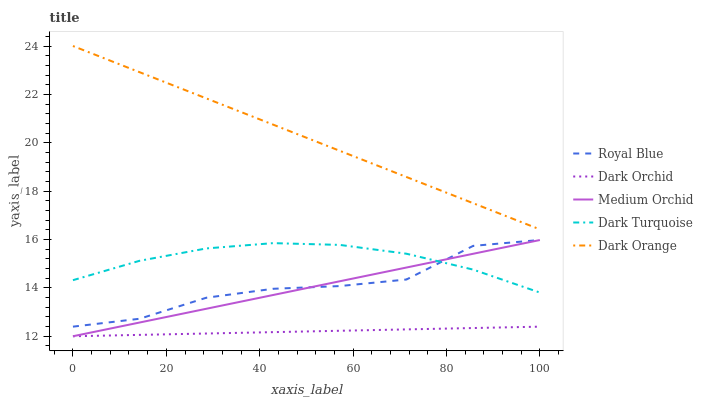Does Dark Orchid have the minimum area under the curve?
Answer yes or no. Yes. Does Dark Orange have the maximum area under the curve?
Answer yes or no. Yes. Does Royal Blue have the minimum area under the curve?
Answer yes or no. No. Does Royal Blue have the maximum area under the curve?
Answer yes or no. No. Is Dark Orchid the smoothest?
Answer yes or no. Yes. Is Royal Blue the roughest?
Answer yes or no. Yes. Is Medium Orchid the smoothest?
Answer yes or no. No. Is Medium Orchid the roughest?
Answer yes or no. No. Does Royal Blue have the lowest value?
Answer yes or no. No. Does Dark Orange have the highest value?
Answer yes or no. Yes. Does Royal Blue have the highest value?
Answer yes or no. No. Is Dark Orchid less than Dark Orange?
Answer yes or no. Yes. Is Dark Orange greater than Medium Orchid?
Answer yes or no. Yes. Does Dark Turquoise intersect Royal Blue?
Answer yes or no. Yes. Is Dark Turquoise less than Royal Blue?
Answer yes or no. No. Is Dark Turquoise greater than Royal Blue?
Answer yes or no. No. Does Dark Orchid intersect Dark Orange?
Answer yes or no. No. 